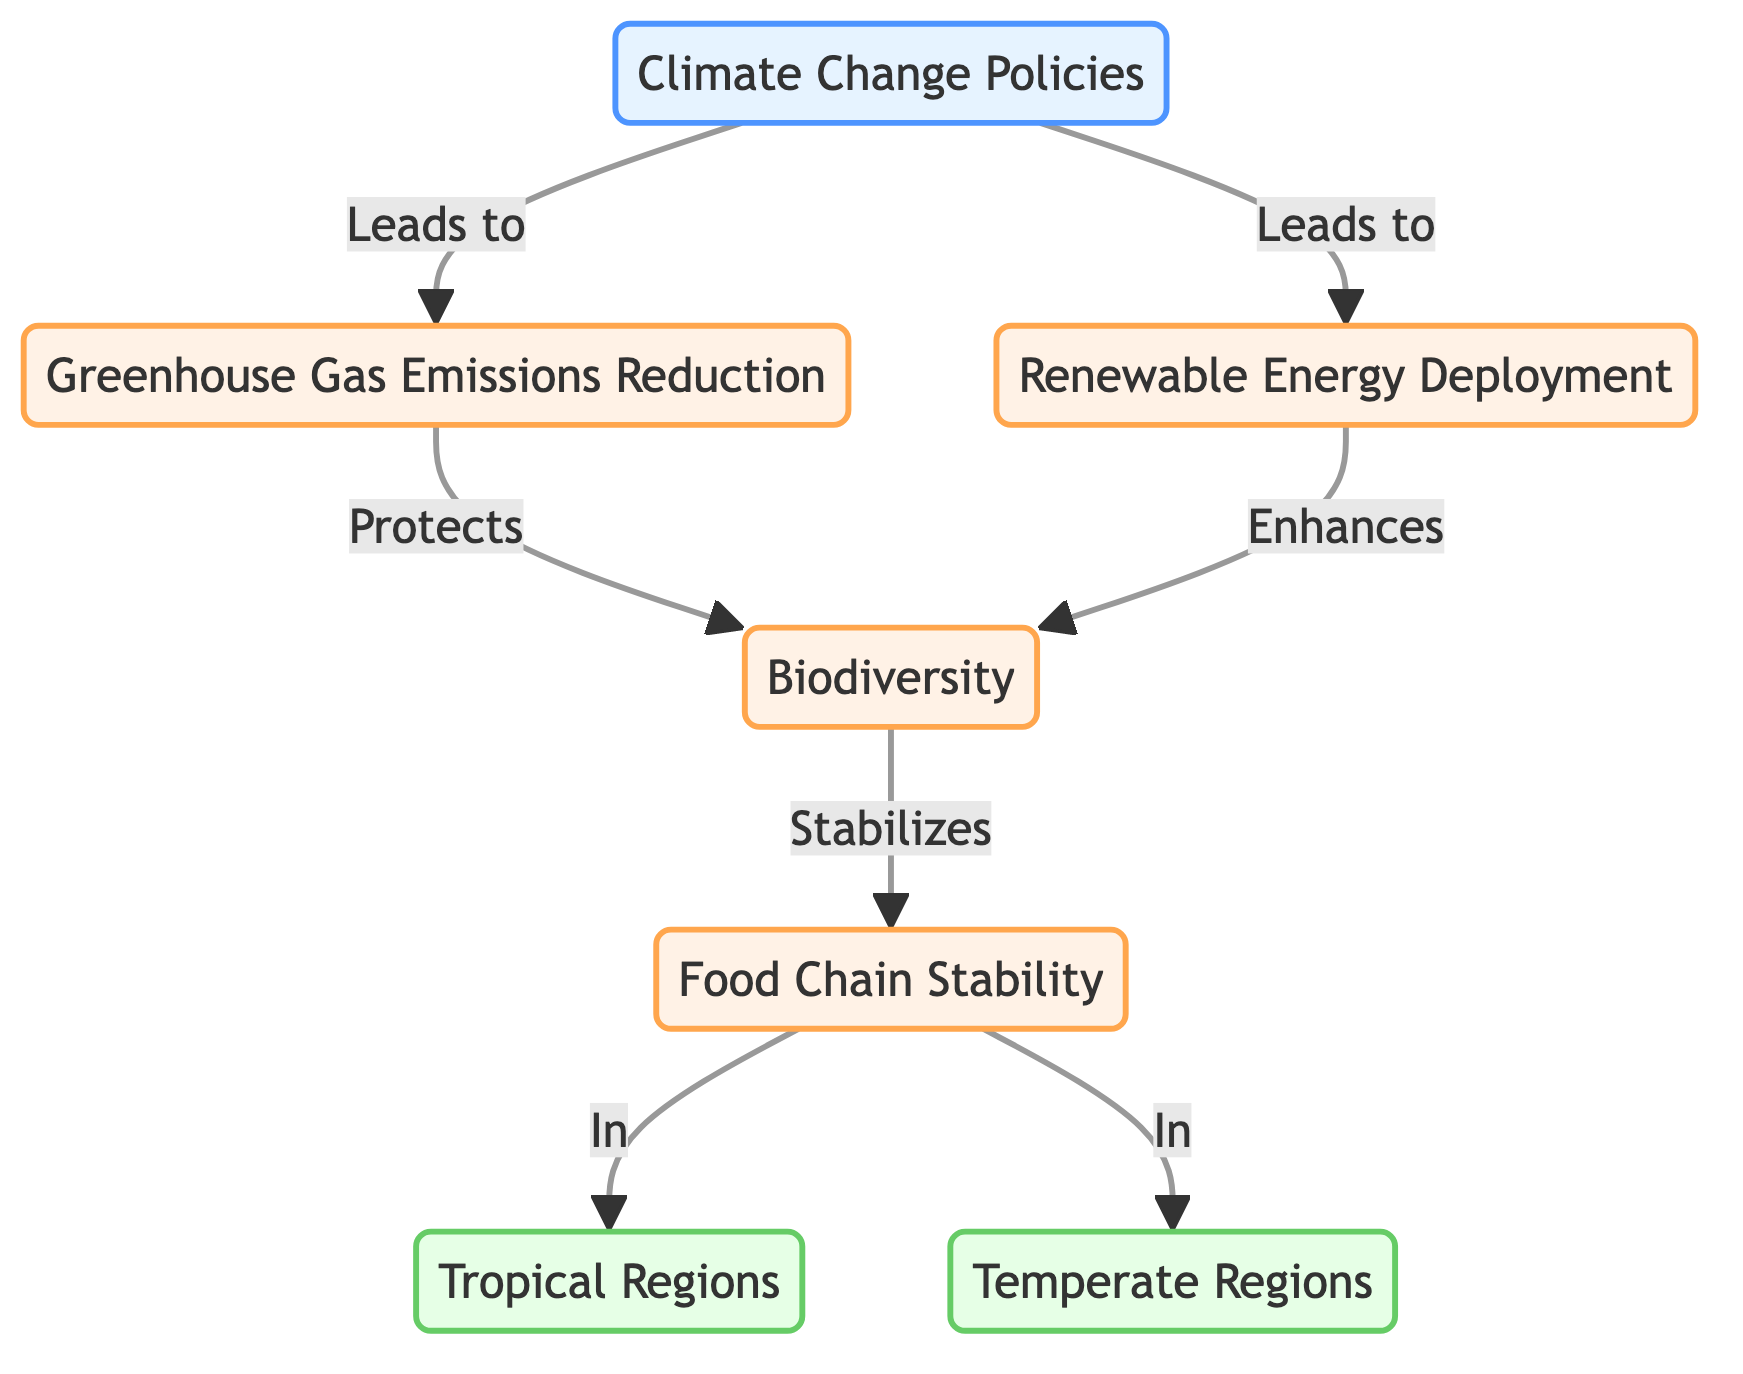What is the first node in the diagram? The first node, labeled "Climate Change Policies," serves as the starting point of the flowchart.
Answer: Climate Change Policies How many effect nodes are present in the diagram? There are four effect nodes in the diagram: "Greenhouse Gas Emissions Reduction," "Renewable Energy Deployment," "Biodiversity," and "Food Chain Stability."
Answer: 4 What relationship exists between "Greenhouse Gas Emissions Reduction" and "Biodiversity"? The diagram indicates that "Greenhouse Gas Emissions Reduction" leads to the protection of "Biodiversity."
Answer: Protects Which regions are shown in the diagram? The diagram features two regions: "Tropical Regions" and "Temperate Regions."
Answer: Tropical Regions, Temperate Regions What does "Biodiversity" stabilize according to the diagram? The diagram illustrates that "Biodiversity" stabilizes "Food Chain Stability" in both regions mentioned.
Answer: Food Chain Stability How does "Renewable Energy Deployment" affect "Biodiversity"? The diagram states that "Renewable Energy Deployment" enhances "Biodiversity," indicating a positive influence.
Answer: Enhances In which regions does "Food Chain Stability" occur? The flowchart specifies that "Food Chain Stability" occurs in both "Tropical Regions" and "Temperate Regions."
Answer: Tropical Regions and Temperate Regions What is the role of "Climate Change Policies" in the diagram? "Climate Change Policies" is the initiating factor that leads to both "Greenhouse Gas Emissions Reduction" and "Renewable Energy Deployment," implying its foundational importance.
Answer: Leads to Which node can be considered the most strategic in improving biodiversity? The node "Renewable Energy Deployment" can be viewed as a strategic driver that enhances "Biodiversity."
Answer: Renewable Energy Deployment 